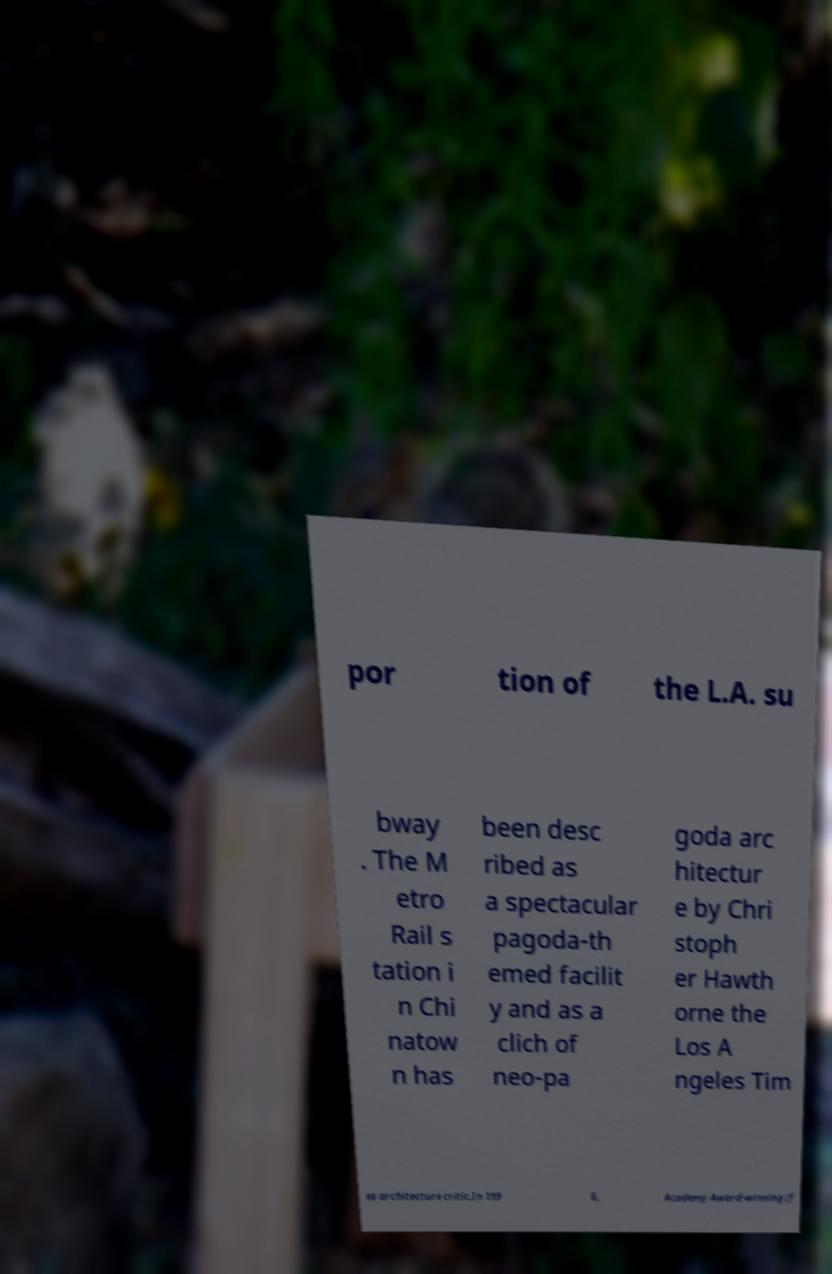Can you accurately transcribe the text from the provided image for me? por tion of the L.A. su bway . The M etro Rail s tation i n Chi natow n has been desc ribed as a spectacular pagoda-th emed facilit y and as a clich of neo-pa goda arc hitectur e by Chri stoph er Hawth orne the Los A ngeles Tim es architecture critic.In 199 6, Academy Award-winning (f 